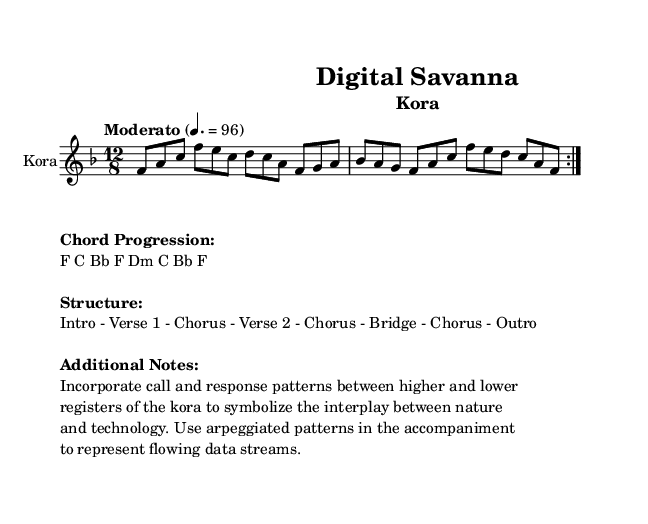What is the key signature of this music? The key signature indicates F major, which is identified by one flat (B flat).
Answer: F major What is the time signature of this music? The time signature is 12/8, which means there are 12 beats in a measure, and the eighth note gets one beat.
Answer: 12/8 What is the tempo marking given in the sheet music? The tempo marking states "Moderato" and indicates a tempo of quarter note equals 96 beats per minute.
Answer: Moderato How many times is the first section repeated? The first section (the volta) is marked to be repeated two times in the score.
Answer: 2 What chord progression is used in this piece? The chord progression listed in the markup section is F, C, B flat, F, D minor, C, B flat, F.
Answer: F C B flat F D minor C B flat F What is the overall structure of this piece? The structure includes an Intro, Verse 1, Chorus, Verse 2, Chorus, Bridge, Chorus, and Outro, which gives a sense of the arrangement of sections.
Answer: Intro - Verse 1 - Chorus - Verse 2 - Chorus - Bridge - Chorus - Outro How does the kora symbolize the interplay between nature and technology in this music? The music incorporates call-and-response patterns and arpeggiated accompaniment, symbolizing flowing data streams, reflecting the relationship between nature and technology.
Answer: Call and response / Arpeggiated patterns 